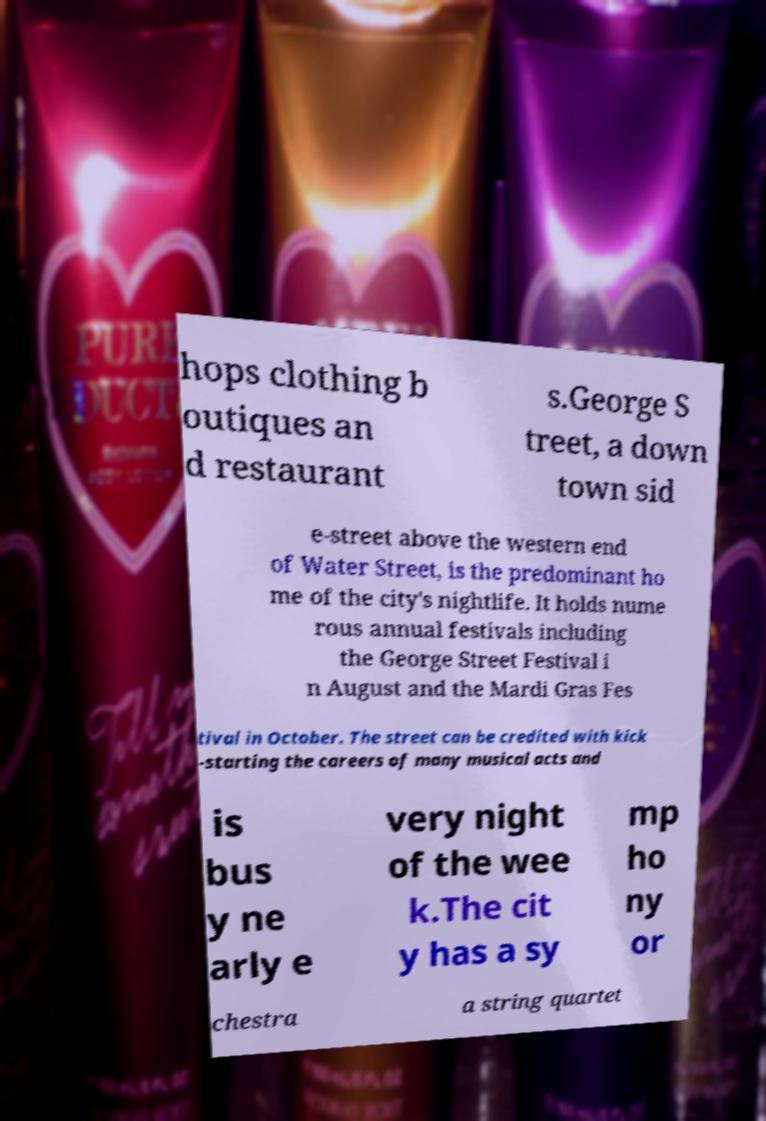There's text embedded in this image that I need extracted. Can you transcribe it verbatim? hops clothing b outiques an d restaurant s.George S treet, a down town sid e-street above the western end of Water Street, is the predominant ho me of the city's nightlife. It holds nume rous annual festivals including the George Street Festival i n August and the Mardi Gras Fes tival in October. The street can be credited with kick -starting the careers of many musical acts and is bus y ne arly e very night of the wee k.The cit y has a sy mp ho ny or chestra a string quartet 